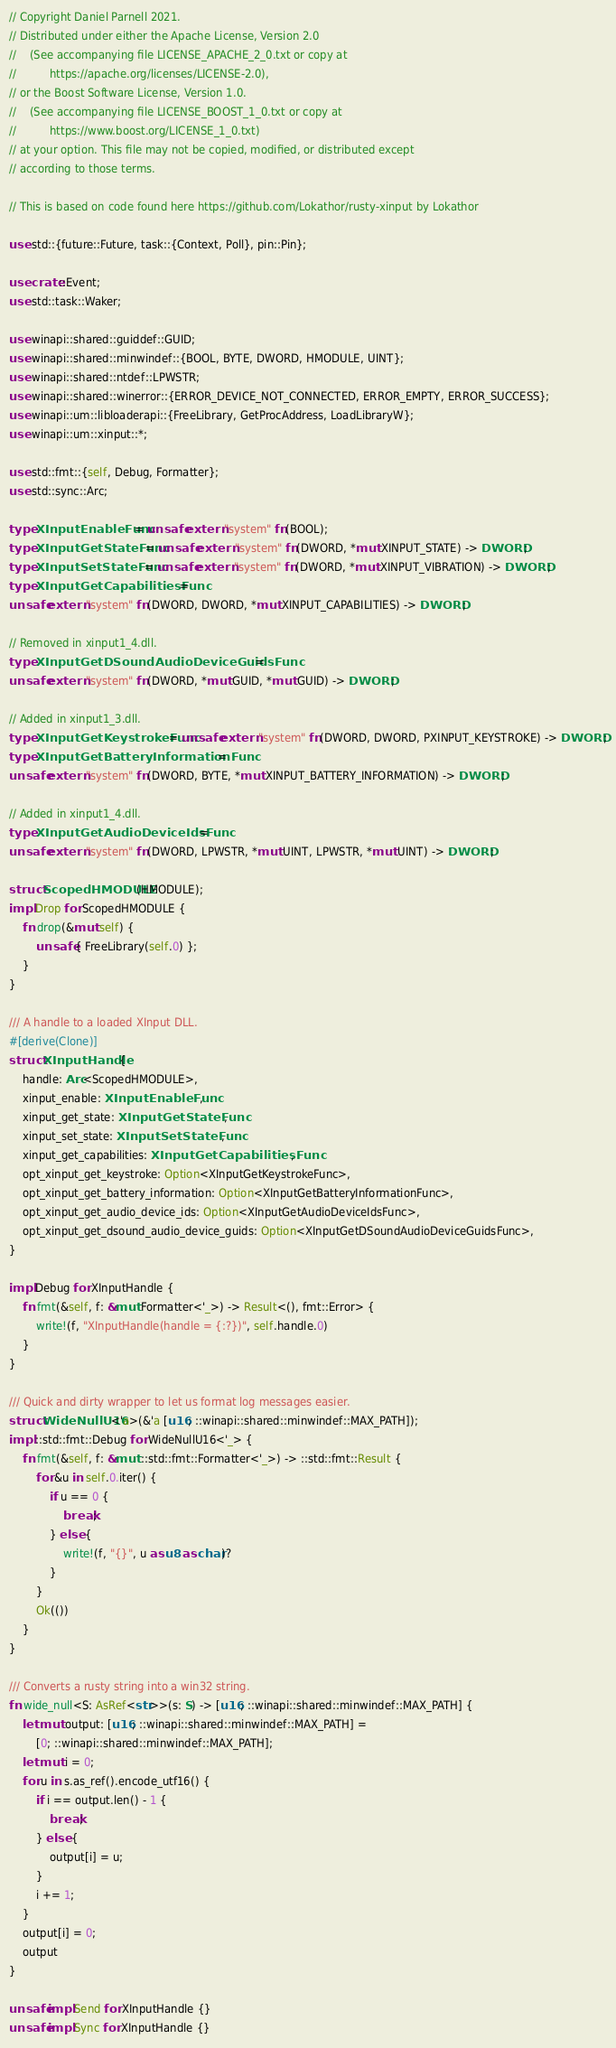Convert code to text. <code><loc_0><loc_0><loc_500><loc_500><_Rust_>// Copyright Daniel Parnell 2021.
// Distributed under either the Apache License, Version 2.0
//    (See accompanying file LICENSE_APACHE_2_0.txt or copy at
//          https://apache.org/licenses/LICENSE-2.0),
// or the Boost Software License, Version 1.0.
//    (See accompanying file LICENSE_BOOST_1_0.txt or copy at
//          https://www.boost.org/LICENSE_1_0.txt)
// at your option. This file may not be copied, modified, or distributed except
// according to those terms.

// This is based on code found here https://github.com/Lokathor/rusty-xinput by Lokathor

use std::{future::Future, task::{Context, Poll}, pin::Pin};

use crate::Event;
use std::task::Waker;

use winapi::shared::guiddef::GUID;
use winapi::shared::minwindef::{BOOL, BYTE, DWORD, HMODULE, UINT};
use winapi::shared::ntdef::LPWSTR;
use winapi::shared::winerror::{ERROR_DEVICE_NOT_CONNECTED, ERROR_EMPTY, ERROR_SUCCESS};
use winapi::um::libloaderapi::{FreeLibrary, GetProcAddress, LoadLibraryW};
use winapi::um::xinput::*;

use std::fmt::{self, Debug, Formatter};
use std::sync::Arc;

type XInputEnableFunc = unsafe extern "system" fn(BOOL);
type XInputGetStateFunc = unsafe extern "system" fn(DWORD, *mut XINPUT_STATE) -> DWORD;
type XInputSetStateFunc = unsafe extern "system" fn(DWORD, *mut XINPUT_VIBRATION) -> DWORD;
type XInputGetCapabilitiesFunc =
unsafe extern "system" fn(DWORD, DWORD, *mut XINPUT_CAPABILITIES) -> DWORD;

// Removed in xinput1_4.dll.
type XInputGetDSoundAudioDeviceGuidsFunc =
unsafe extern "system" fn(DWORD, *mut GUID, *mut GUID) -> DWORD;

// Added in xinput1_3.dll.
type XInputGetKeystrokeFunc = unsafe extern "system" fn(DWORD, DWORD, PXINPUT_KEYSTROKE) -> DWORD;
type XInputGetBatteryInformationFunc =
unsafe extern "system" fn(DWORD, BYTE, *mut XINPUT_BATTERY_INFORMATION) -> DWORD;

// Added in xinput1_4.dll.
type XInputGetAudioDeviceIdsFunc =
unsafe extern "system" fn(DWORD, LPWSTR, *mut UINT, LPWSTR, *mut UINT) -> DWORD;

struct ScopedHMODULE(HMODULE);
impl Drop for ScopedHMODULE {
    fn drop(&mut self) {
        unsafe { FreeLibrary(self.0) };
    }
}

/// A handle to a loaded XInput DLL.
#[derive(Clone)]
struct XInputHandle {
    handle: Arc<ScopedHMODULE>,
    xinput_enable: XInputEnableFunc,
    xinput_get_state: XInputGetStateFunc,
    xinput_set_state: XInputSetStateFunc,
    xinput_get_capabilities: XInputGetCapabilitiesFunc,
    opt_xinput_get_keystroke: Option<XInputGetKeystrokeFunc>,
    opt_xinput_get_battery_information: Option<XInputGetBatteryInformationFunc>,
    opt_xinput_get_audio_device_ids: Option<XInputGetAudioDeviceIdsFunc>,
    opt_xinput_get_dsound_audio_device_guids: Option<XInputGetDSoundAudioDeviceGuidsFunc>,
}

impl Debug for XInputHandle {
    fn fmt(&self, f: &mut Formatter<'_>) -> Result<(), fmt::Error> {
        write!(f, "XInputHandle(handle = {:?})", self.handle.0)
    }
}

/// Quick and dirty wrapper to let us format log messages easier.
struct WideNullU16<'a>(&'a [u16; ::winapi::shared::minwindef::MAX_PATH]);
impl ::std::fmt::Debug for WideNullU16<'_> {
    fn fmt(&self, f: &mut ::std::fmt::Formatter<'_>) -> ::std::fmt::Result {
        for &u in self.0.iter() {
            if u == 0 {
                break;
            } else {
                write!(f, "{}", u as u8 as char)?
            }
        }
        Ok(())
    }
}

/// Converts a rusty string into a win32 string.
fn wide_null<S: AsRef<str>>(s: S) -> [u16; ::winapi::shared::minwindef::MAX_PATH] {
    let mut output: [u16; ::winapi::shared::minwindef::MAX_PATH] =
        [0; ::winapi::shared::minwindef::MAX_PATH];
    let mut i = 0;
    for u in s.as_ref().encode_utf16() {
        if i == output.len() - 1 {
            break;
        } else {
            output[i] = u;
        }
        i += 1;
    }
    output[i] = 0;
    output
}

unsafe impl Send for XInputHandle {}
unsafe impl Sync for XInputHandle {}
</code> 